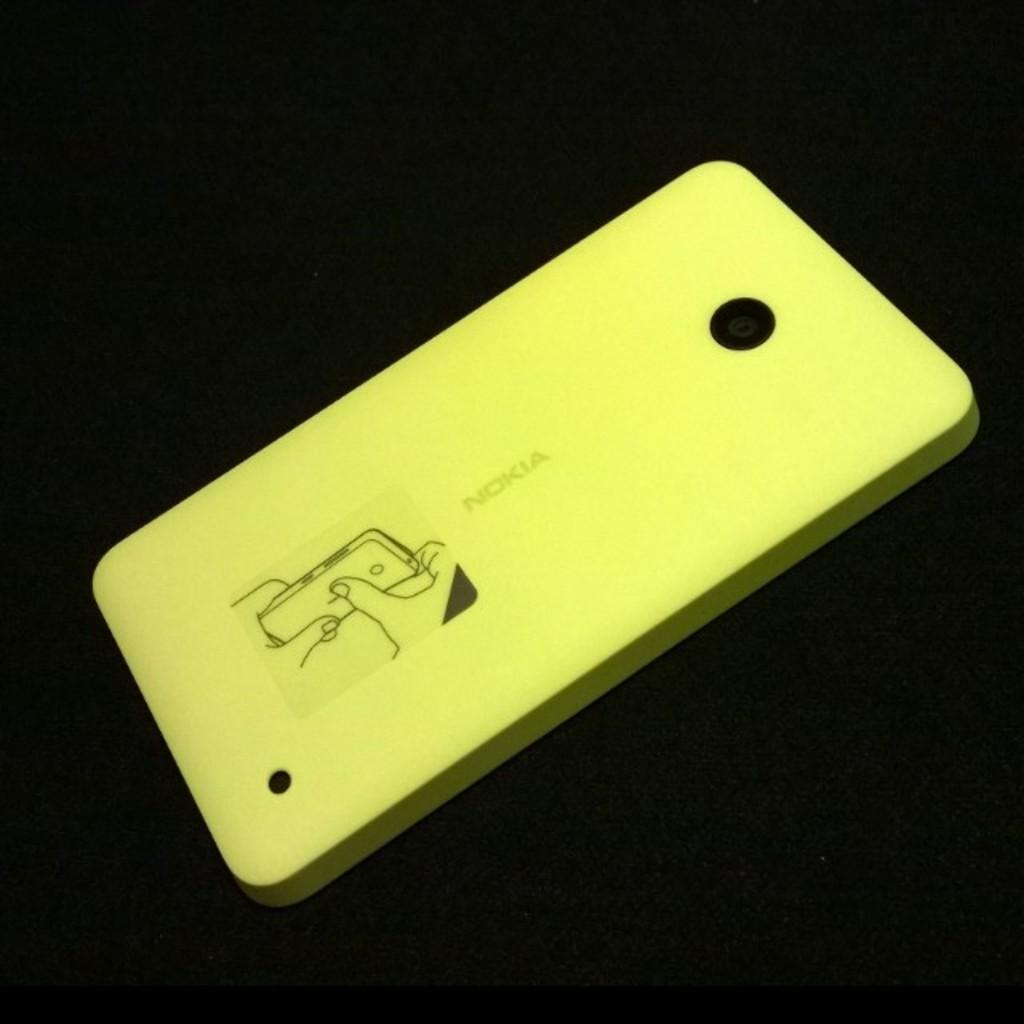<image>
Relay a brief, clear account of the picture shown. A yellow Nokia phone rests diagonally on a dark surface. 